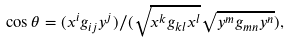Convert formula to latex. <formula><loc_0><loc_0><loc_500><loc_500>\cos \theta = ( x ^ { i } g _ { i j } y ^ { j } ) / ( \sqrt { x ^ { k } g _ { k l } x ^ { l } } \sqrt { y ^ { m } g _ { m n } y ^ { n } } ) ,</formula> 